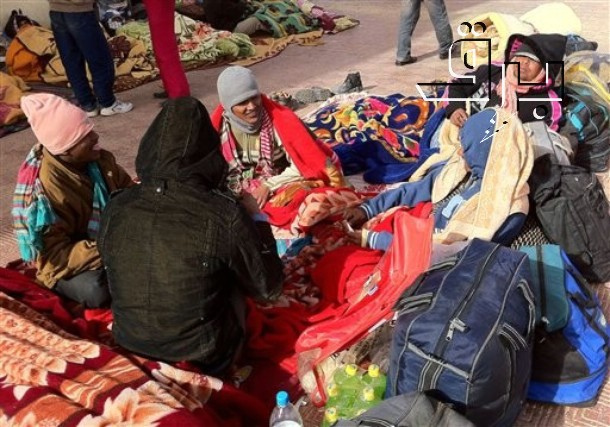What could have happened just before this moment was captured? Just before this moment, it's possible that these individuals were moving through the city, looking for a spot to rest and share a meal. Perhaps they had been walking for hours, sharing stories and laughing despite the cold. When they found this spot, they spread out their blankets, unpacked their bags, and sat down to take a break. Someone might have handed out bottles of water while another person found something amusing in their bag, causing the others to gather around in curiosity and amusement. This would explain the relaxed yet attentive postures and the sense of camaraderie captured in the image. 